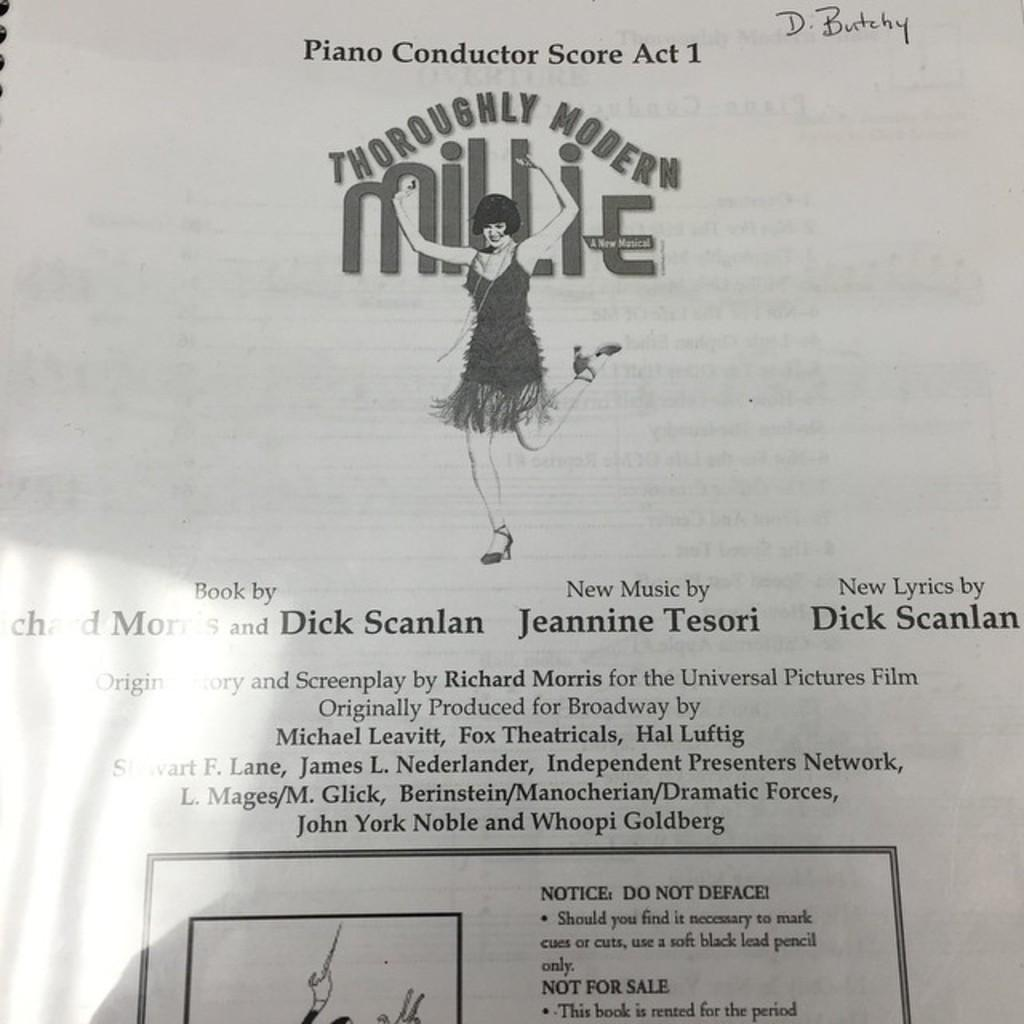What can be found at the bottom of the image? There is text at the bottom of the image. What is the main feature in the middle of the image? There is a diagram of a woman on paper in the middle of the image. How many pizzas are being thought about in the image? There are no pizzas or thoughts present in the image; it only contains text and a diagram of a woman on paper. 